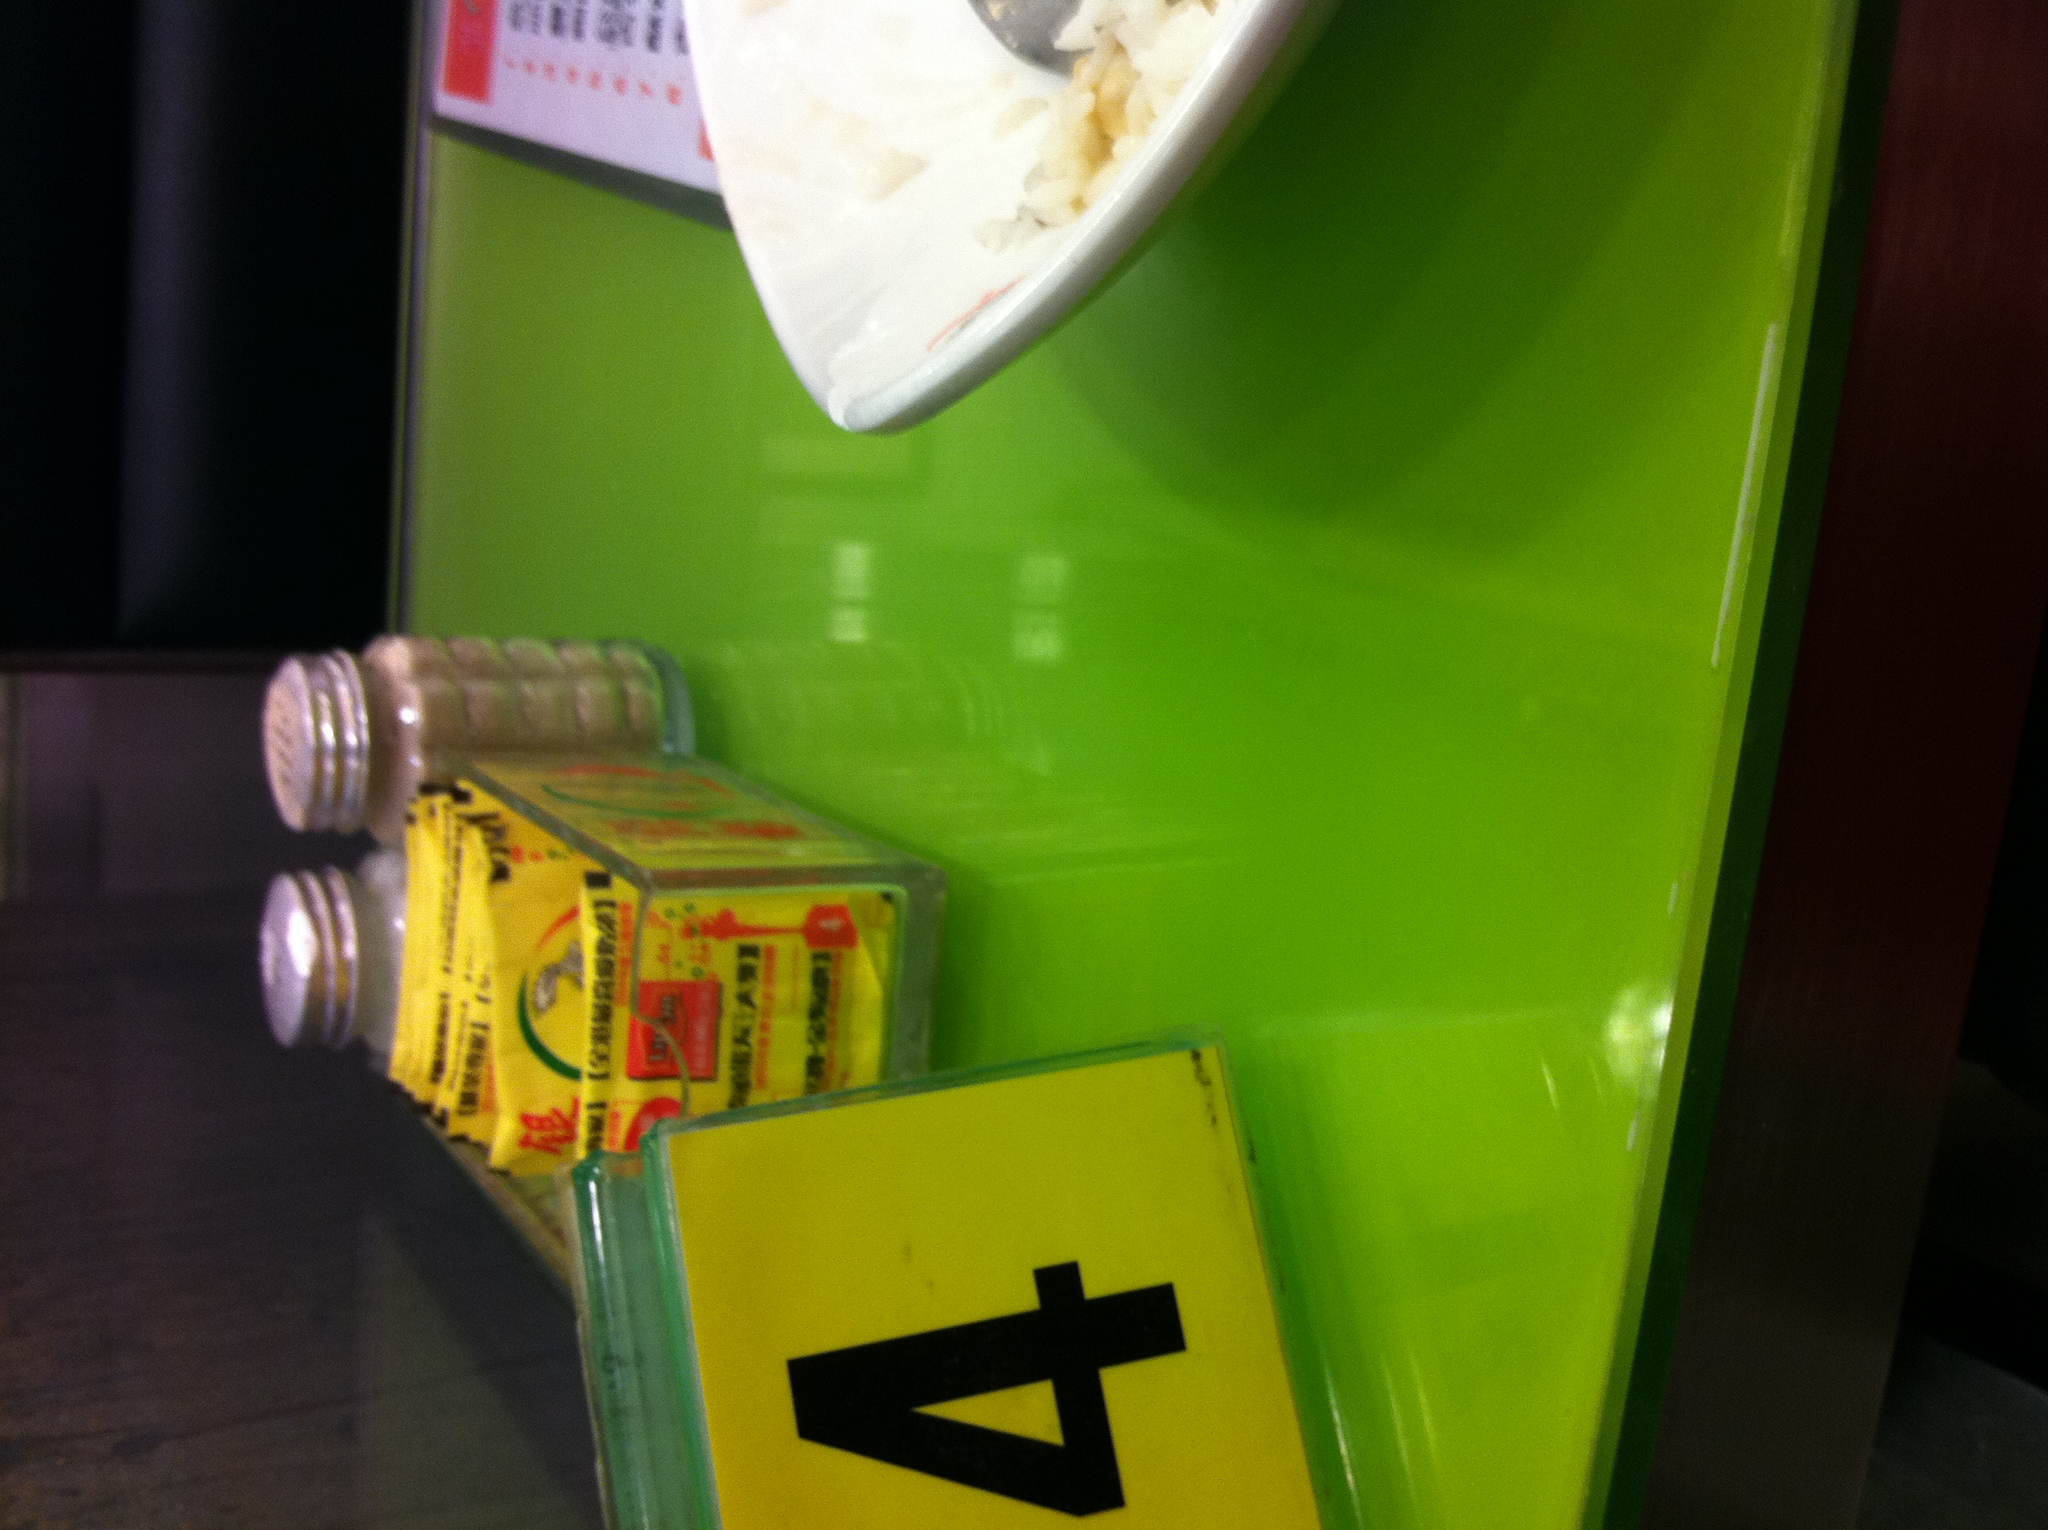Imagine you are an alien who has just landed on Earth. How would you describe this scene? As an alien observer, I find myself intrigued by the scene before me. There is a flat, horizontal platform with a smooth, green surface. Upon this platform lies an assortment of objects: a flat container filled with small, white grains, possibly some form of sustenance, and a metallic tool implanted in the grains. Two cylindrical containers rest beside it, holding substances of varying granular sizes, likely to enhance the flavor of the sustenance. Additionally, a brightly colored rectangular sign displays a solitary numeral, possibly an identifier or marker. Each element speaks of a methodical arrangement, indicative of a culture with dietary rituals and practices. 